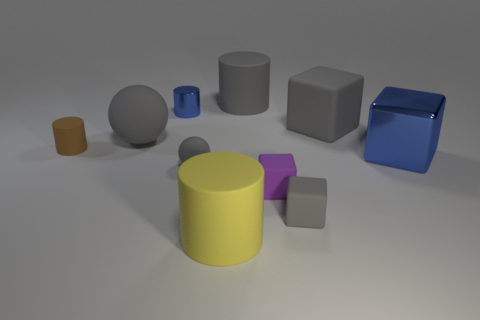Is there another blue block that has the same size as the blue metal block?
Keep it short and to the point. No. Do the yellow matte object and the gray cube in front of the shiny cube have the same size?
Provide a succinct answer. No. Is the number of metallic cubes on the left side of the tiny brown object the same as the number of shiny cylinders that are in front of the blue cylinder?
Your answer should be very brief. Yes. What shape is the other metallic thing that is the same color as the big metal object?
Provide a short and direct response. Cylinder. There is a large cylinder that is behind the yellow rubber cylinder; what is its material?
Give a very brief answer. Rubber. Does the purple cube have the same size as the blue cylinder?
Your response must be concise. Yes. Is the number of blocks that are behind the small purple object greater than the number of large purple things?
Offer a very short reply. Yes. What is the size of the gray cylinder that is made of the same material as the brown cylinder?
Your answer should be compact. Large. There is a blue cylinder; are there any small metal cylinders behind it?
Ensure brevity in your answer.  No. Does the tiny purple matte thing have the same shape as the yellow thing?
Provide a succinct answer. No. 